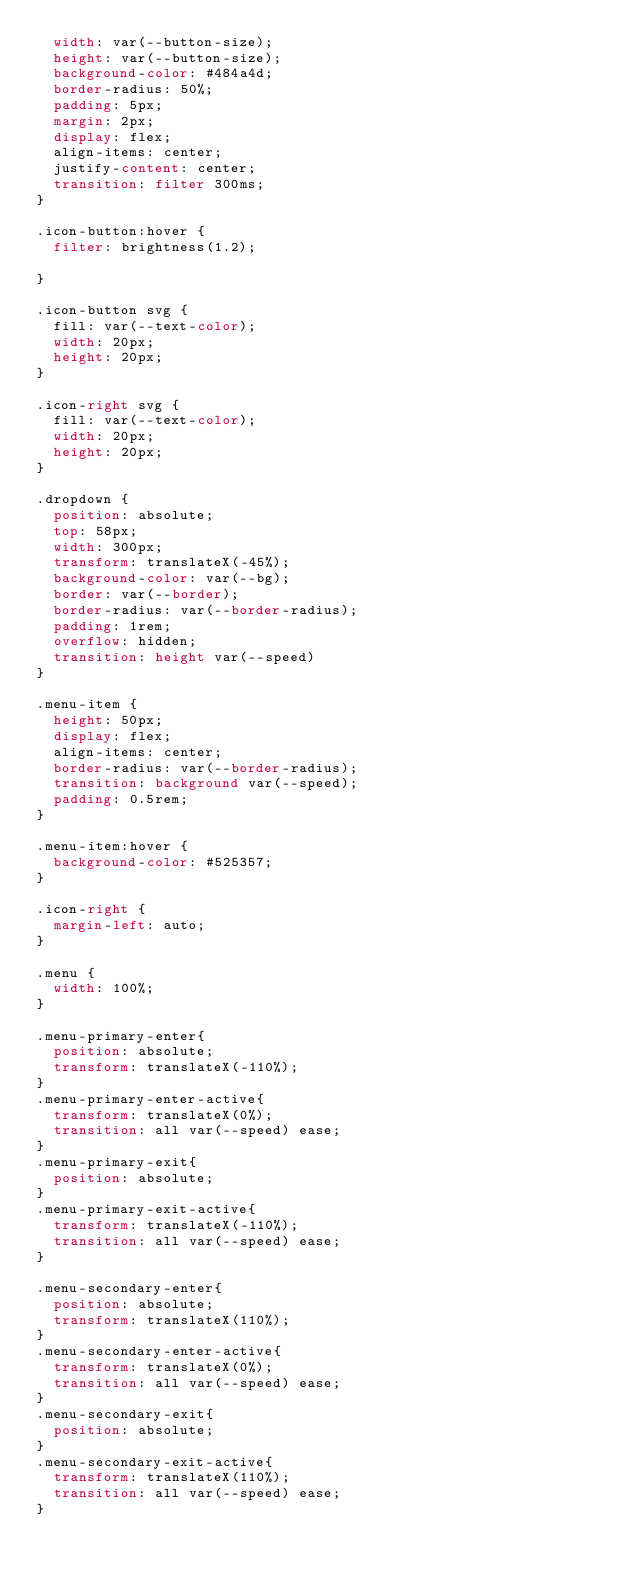Convert code to text. <code><loc_0><loc_0><loc_500><loc_500><_CSS_>  width: var(--button-size);
  height: var(--button-size);
  background-color: #484a4d;
  border-radius: 50%;
  padding: 5px;
  margin: 2px;
  display: flex;
  align-items: center;
  justify-content: center;
  transition: filter 300ms;
}

.icon-button:hover {
  filter: brightness(1.2);

}

.icon-button svg {
  fill: var(--text-color);
  width: 20px;
  height: 20px;
}

.icon-right svg {
  fill: var(--text-color);
  width: 20px;
  height: 20px;
}

.dropdown {
  position: absolute;
  top: 58px;
  width: 300px;
  transform: translateX(-45%);
  background-color: var(--bg);
  border: var(--border);
  border-radius: var(--border-radius);
  padding: 1rem;
  overflow: hidden;
  transition: height var(--speed) 
}

.menu-item {
  height: 50px;
  display: flex;
  align-items: center;
  border-radius: var(--border-radius);
  transition: background var(--speed);
  padding: 0.5rem;
}

.menu-item:hover {
  background-color: #525357;
}

.icon-right {
  margin-left: auto;
}

.menu {
  width: 100%;
}

.menu-primary-enter{
  position: absolute;
  transform: translateX(-110%);
}
.menu-primary-enter-active{
  transform: translateX(0%);
  transition: all var(--speed) ease;
}
.menu-primary-exit{
  position: absolute;
}
.menu-primary-exit-active{
  transform: translateX(-110%);
  transition: all var(--speed) ease;
}

.menu-secondary-enter{
  position: absolute;
  transform: translateX(110%);
}
.menu-secondary-enter-active{
  transform: translateX(0%);
  transition: all var(--speed) ease;
}
.menu-secondary-exit{
  position: absolute;
}
.menu-secondary-exit-active{
  transform: translateX(110%);
  transition: all var(--speed) ease;
}</code> 